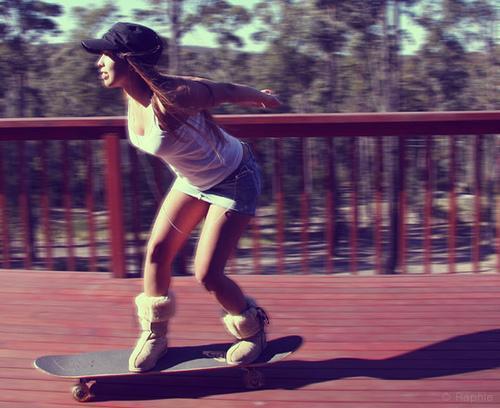How many people in the picture?
Give a very brief answer. 1. How many cars aare parked next to the pile of garbage bags?
Give a very brief answer. 0. 